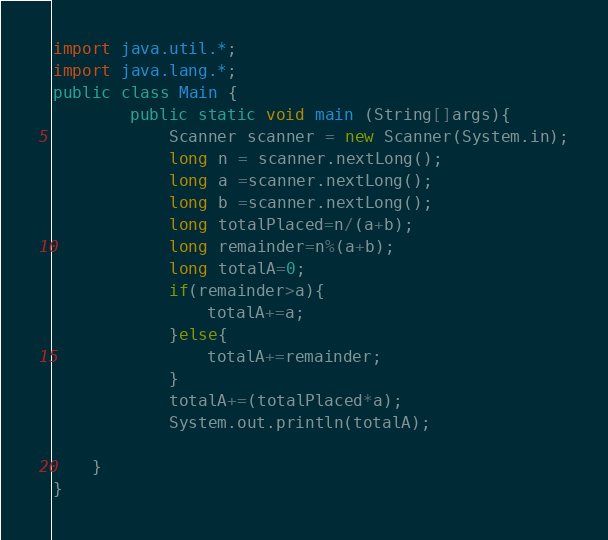Convert code to text. <code><loc_0><loc_0><loc_500><loc_500><_Java_>import java.util.*;
import java.lang.*;
public class Main {
        public static void main (String[]args){
            Scanner scanner = new Scanner(System.in);
            long n = scanner.nextLong();
            long a =scanner.nextLong();
            long b =scanner.nextLong();
            long totalPlaced=n/(a+b);
            long remainder=n%(a+b);
            long totalA=0;
            if(remainder>a){
                totalA+=a;
            }else{
                totalA+=remainder;
            }
            totalA+=(totalPlaced*a);
            System.out.println(totalA);

    }
}



</code> 